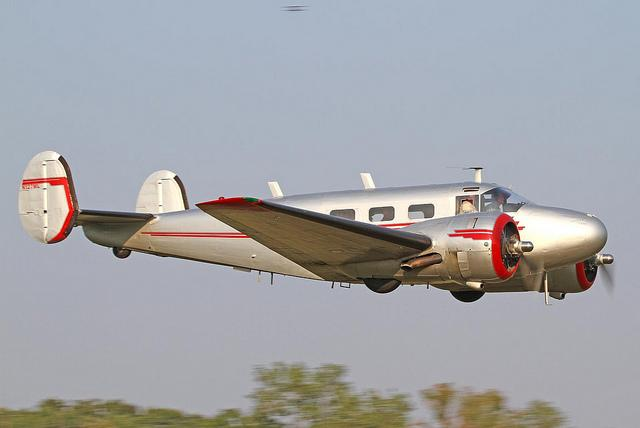What is seen in the sky? airplane 